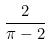Convert formula to latex. <formula><loc_0><loc_0><loc_500><loc_500>\frac { 2 } { \pi - 2 }</formula> 